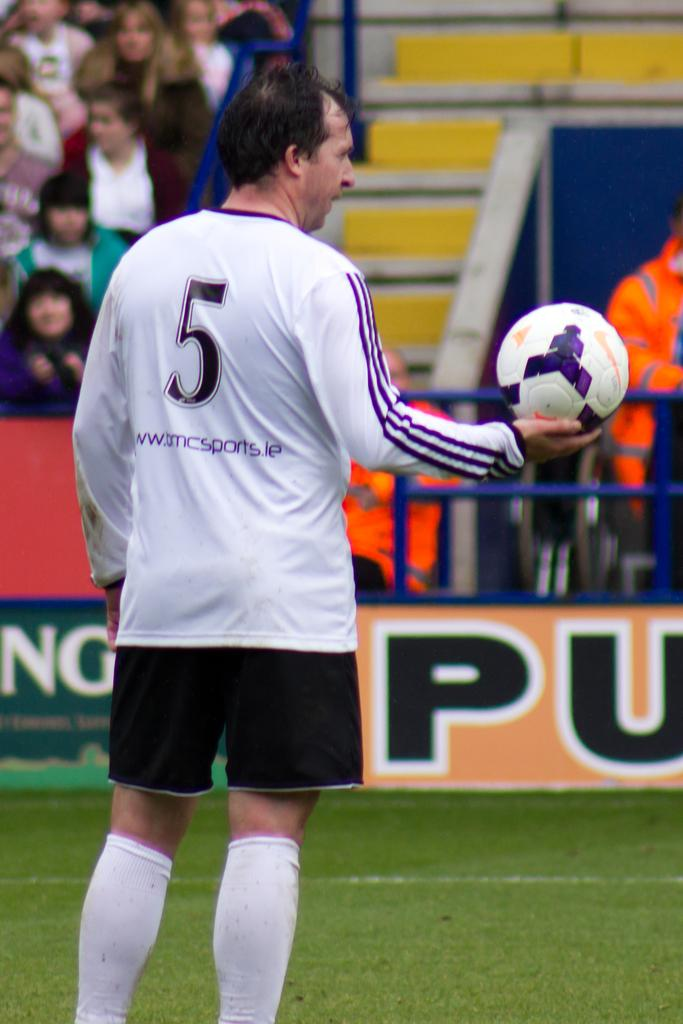<image>
Give a short and clear explanation of the subsequent image. a player with the number 5 on their jersey 